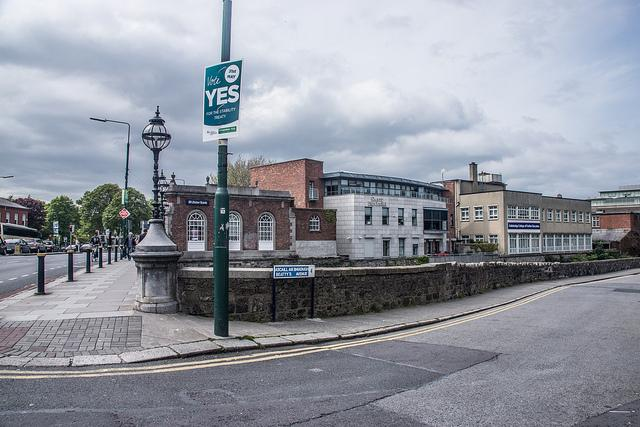The clouds here indicate what might happen? Please explain your reasoning. rain. The sky is gray and the sun is not visible. 